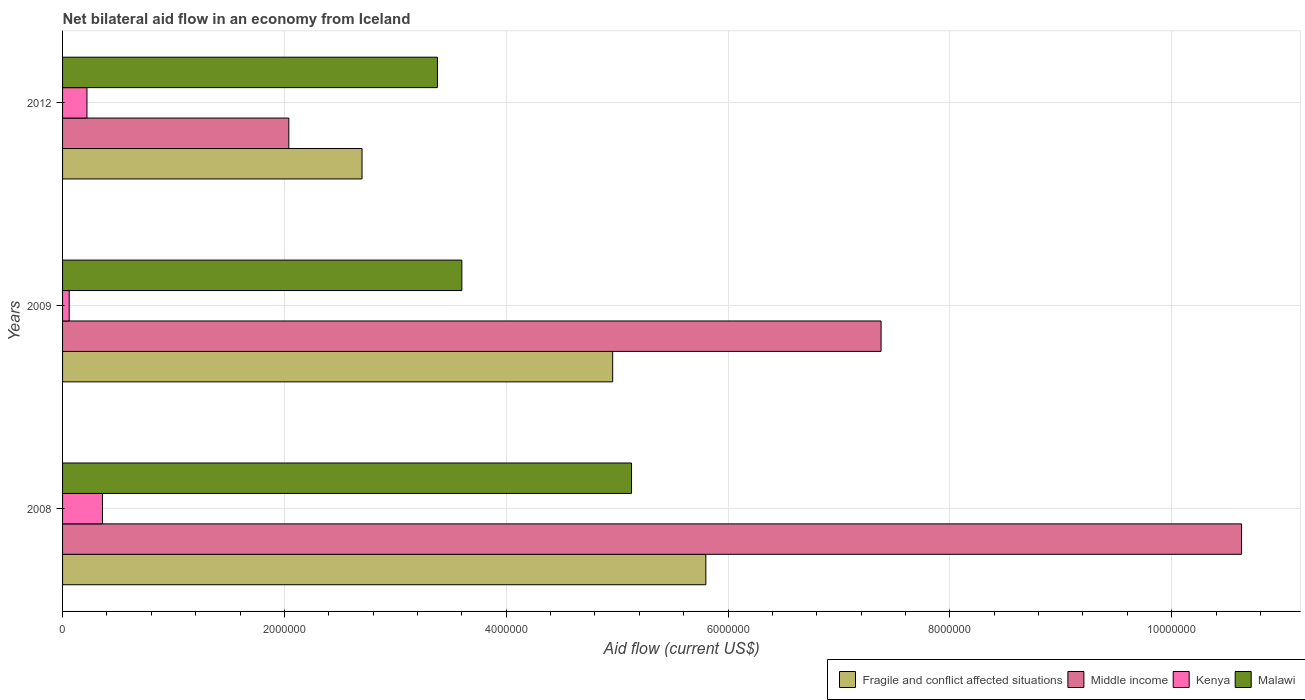How many different coloured bars are there?
Provide a succinct answer. 4. How many groups of bars are there?
Your response must be concise. 3. Are the number of bars per tick equal to the number of legend labels?
Offer a very short reply. Yes. Are the number of bars on each tick of the Y-axis equal?
Provide a short and direct response. Yes. How many bars are there on the 3rd tick from the top?
Keep it short and to the point. 4. What is the net bilateral aid flow in Kenya in 2009?
Your answer should be compact. 6.00e+04. Across all years, what is the minimum net bilateral aid flow in Malawi?
Your response must be concise. 3.38e+06. In which year was the net bilateral aid flow in Kenya maximum?
Provide a succinct answer. 2008. In which year was the net bilateral aid flow in Malawi minimum?
Keep it short and to the point. 2012. What is the total net bilateral aid flow in Middle income in the graph?
Your response must be concise. 2.00e+07. What is the difference between the net bilateral aid flow in Malawi in 2009 and that in 2012?
Your response must be concise. 2.20e+05. What is the difference between the net bilateral aid flow in Malawi in 2009 and the net bilateral aid flow in Middle income in 2012?
Make the answer very short. 1.56e+06. What is the average net bilateral aid flow in Kenya per year?
Your answer should be very brief. 2.13e+05. In the year 2008, what is the difference between the net bilateral aid flow in Middle income and net bilateral aid flow in Kenya?
Your response must be concise. 1.03e+07. In how many years, is the net bilateral aid flow in Kenya greater than 3600000 US$?
Offer a terse response. 0. What is the ratio of the net bilateral aid flow in Middle income in 2008 to that in 2009?
Offer a terse response. 1.44. What is the difference between the highest and the second highest net bilateral aid flow in Fragile and conflict affected situations?
Provide a short and direct response. 8.40e+05. What is the difference between the highest and the lowest net bilateral aid flow in Middle income?
Your answer should be compact. 8.59e+06. In how many years, is the net bilateral aid flow in Kenya greater than the average net bilateral aid flow in Kenya taken over all years?
Offer a terse response. 2. Is the sum of the net bilateral aid flow in Middle income in 2008 and 2012 greater than the maximum net bilateral aid flow in Malawi across all years?
Give a very brief answer. Yes. Is it the case that in every year, the sum of the net bilateral aid flow in Kenya and net bilateral aid flow in Fragile and conflict affected situations is greater than the sum of net bilateral aid flow in Middle income and net bilateral aid flow in Malawi?
Provide a short and direct response. Yes. What does the 4th bar from the top in 2008 represents?
Ensure brevity in your answer.  Fragile and conflict affected situations. What does the 4th bar from the bottom in 2012 represents?
Your answer should be compact. Malawi. Are all the bars in the graph horizontal?
Keep it short and to the point. Yes. How many years are there in the graph?
Ensure brevity in your answer.  3. Are the values on the major ticks of X-axis written in scientific E-notation?
Provide a short and direct response. No. Where does the legend appear in the graph?
Make the answer very short. Bottom right. How many legend labels are there?
Your answer should be very brief. 4. What is the title of the graph?
Make the answer very short. Net bilateral aid flow in an economy from Iceland. What is the label or title of the X-axis?
Your response must be concise. Aid flow (current US$). What is the Aid flow (current US$) in Fragile and conflict affected situations in 2008?
Keep it short and to the point. 5.80e+06. What is the Aid flow (current US$) in Middle income in 2008?
Provide a short and direct response. 1.06e+07. What is the Aid flow (current US$) of Malawi in 2008?
Keep it short and to the point. 5.13e+06. What is the Aid flow (current US$) in Fragile and conflict affected situations in 2009?
Ensure brevity in your answer.  4.96e+06. What is the Aid flow (current US$) in Middle income in 2009?
Offer a terse response. 7.38e+06. What is the Aid flow (current US$) in Kenya in 2009?
Make the answer very short. 6.00e+04. What is the Aid flow (current US$) of Malawi in 2009?
Offer a terse response. 3.60e+06. What is the Aid flow (current US$) of Fragile and conflict affected situations in 2012?
Make the answer very short. 2.70e+06. What is the Aid flow (current US$) of Middle income in 2012?
Give a very brief answer. 2.04e+06. What is the Aid flow (current US$) of Malawi in 2012?
Offer a terse response. 3.38e+06. Across all years, what is the maximum Aid flow (current US$) of Fragile and conflict affected situations?
Offer a very short reply. 5.80e+06. Across all years, what is the maximum Aid flow (current US$) of Middle income?
Provide a succinct answer. 1.06e+07. Across all years, what is the maximum Aid flow (current US$) of Kenya?
Give a very brief answer. 3.60e+05. Across all years, what is the maximum Aid flow (current US$) of Malawi?
Provide a short and direct response. 5.13e+06. Across all years, what is the minimum Aid flow (current US$) in Fragile and conflict affected situations?
Keep it short and to the point. 2.70e+06. Across all years, what is the minimum Aid flow (current US$) of Middle income?
Your response must be concise. 2.04e+06. Across all years, what is the minimum Aid flow (current US$) in Malawi?
Provide a succinct answer. 3.38e+06. What is the total Aid flow (current US$) of Fragile and conflict affected situations in the graph?
Your answer should be compact. 1.35e+07. What is the total Aid flow (current US$) in Middle income in the graph?
Your response must be concise. 2.00e+07. What is the total Aid flow (current US$) of Kenya in the graph?
Your response must be concise. 6.40e+05. What is the total Aid flow (current US$) of Malawi in the graph?
Ensure brevity in your answer.  1.21e+07. What is the difference between the Aid flow (current US$) of Fragile and conflict affected situations in 2008 and that in 2009?
Provide a short and direct response. 8.40e+05. What is the difference between the Aid flow (current US$) of Middle income in 2008 and that in 2009?
Offer a very short reply. 3.25e+06. What is the difference between the Aid flow (current US$) of Malawi in 2008 and that in 2009?
Your answer should be compact. 1.53e+06. What is the difference between the Aid flow (current US$) of Fragile and conflict affected situations in 2008 and that in 2012?
Your answer should be very brief. 3.10e+06. What is the difference between the Aid flow (current US$) in Middle income in 2008 and that in 2012?
Give a very brief answer. 8.59e+06. What is the difference between the Aid flow (current US$) of Malawi in 2008 and that in 2012?
Give a very brief answer. 1.75e+06. What is the difference between the Aid flow (current US$) in Fragile and conflict affected situations in 2009 and that in 2012?
Offer a terse response. 2.26e+06. What is the difference between the Aid flow (current US$) in Middle income in 2009 and that in 2012?
Keep it short and to the point. 5.34e+06. What is the difference between the Aid flow (current US$) in Kenya in 2009 and that in 2012?
Your answer should be very brief. -1.60e+05. What is the difference between the Aid flow (current US$) in Malawi in 2009 and that in 2012?
Your answer should be compact. 2.20e+05. What is the difference between the Aid flow (current US$) in Fragile and conflict affected situations in 2008 and the Aid flow (current US$) in Middle income in 2009?
Offer a terse response. -1.58e+06. What is the difference between the Aid flow (current US$) of Fragile and conflict affected situations in 2008 and the Aid flow (current US$) of Kenya in 2009?
Your answer should be very brief. 5.74e+06. What is the difference between the Aid flow (current US$) of Fragile and conflict affected situations in 2008 and the Aid flow (current US$) of Malawi in 2009?
Your answer should be very brief. 2.20e+06. What is the difference between the Aid flow (current US$) in Middle income in 2008 and the Aid flow (current US$) in Kenya in 2009?
Provide a succinct answer. 1.06e+07. What is the difference between the Aid flow (current US$) in Middle income in 2008 and the Aid flow (current US$) in Malawi in 2009?
Make the answer very short. 7.03e+06. What is the difference between the Aid flow (current US$) of Kenya in 2008 and the Aid flow (current US$) of Malawi in 2009?
Your response must be concise. -3.24e+06. What is the difference between the Aid flow (current US$) in Fragile and conflict affected situations in 2008 and the Aid flow (current US$) in Middle income in 2012?
Make the answer very short. 3.76e+06. What is the difference between the Aid flow (current US$) of Fragile and conflict affected situations in 2008 and the Aid flow (current US$) of Kenya in 2012?
Keep it short and to the point. 5.58e+06. What is the difference between the Aid flow (current US$) in Fragile and conflict affected situations in 2008 and the Aid flow (current US$) in Malawi in 2012?
Provide a succinct answer. 2.42e+06. What is the difference between the Aid flow (current US$) in Middle income in 2008 and the Aid flow (current US$) in Kenya in 2012?
Provide a short and direct response. 1.04e+07. What is the difference between the Aid flow (current US$) in Middle income in 2008 and the Aid flow (current US$) in Malawi in 2012?
Ensure brevity in your answer.  7.25e+06. What is the difference between the Aid flow (current US$) of Kenya in 2008 and the Aid flow (current US$) of Malawi in 2012?
Your answer should be very brief. -3.02e+06. What is the difference between the Aid flow (current US$) in Fragile and conflict affected situations in 2009 and the Aid flow (current US$) in Middle income in 2012?
Your response must be concise. 2.92e+06. What is the difference between the Aid flow (current US$) of Fragile and conflict affected situations in 2009 and the Aid flow (current US$) of Kenya in 2012?
Your response must be concise. 4.74e+06. What is the difference between the Aid flow (current US$) in Fragile and conflict affected situations in 2009 and the Aid flow (current US$) in Malawi in 2012?
Keep it short and to the point. 1.58e+06. What is the difference between the Aid flow (current US$) in Middle income in 2009 and the Aid flow (current US$) in Kenya in 2012?
Give a very brief answer. 7.16e+06. What is the difference between the Aid flow (current US$) of Kenya in 2009 and the Aid flow (current US$) of Malawi in 2012?
Keep it short and to the point. -3.32e+06. What is the average Aid flow (current US$) of Fragile and conflict affected situations per year?
Keep it short and to the point. 4.49e+06. What is the average Aid flow (current US$) in Middle income per year?
Give a very brief answer. 6.68e+06. What is the average Aid flow (current US$) of Kenya per year?
Provide a short and direct response. 2.13e+05. What is the average Aid flow (current US$) of Malawi per year?
Ensure brevity in your answer.  4.04e+06. In the year 2008, what is the difference between the Aid flow (current US$) in Fragile and conflict affected situations and Aid flow (current US$) in Middle income?
Provide a short and direct response. -4.83e+06. In the year 2008, what is the difference between the Aid flow (current US$) of Fragile and conflict affected situations and Aid flow (current US$) of Kenya?
Keep it short and to the point. 5.44e+06. In the year 2008, what is the difference between the Aid flow (current US$) of Fragile and conflict affected situations and Aid flow (current US$) of Malawi?
Ensure brevity in your answer.  6.70e+05. In the year 2008, what is the difference between the Aid flow (current US$) in Middle income and Aid flow (current US$) in Kenya?
Your response must be concise. 1.03e+07. In the year 2008, what is the difference between the Aid flow (current US$) in Middle income and Aid flow (current US$) in Malawi?
Provide a succinct answer. 5.50e+06. In the year 2008, what is the difference between the Aid flow (current US$) in Kenya and Aid flow (current US$) in Malawi?
Provide a short and direct response. -4.77e+06. In the year 2009, what is the difference between the Aid flow (current US$) in Fragile and conflict affected situations and Aid flow (current US$) in Middle income?
Offer a terse response. -2.42e+06. In the year 2009, what is the difference between the Aid flow (current US$) of Fragile and conflict affected situations and Aid flow (current US$) of Kenya?
Keep it short and to the point. 4.90e+06. In the year 2009, what is the difference between the Aid flow (current US$) of Fragile and conflict affected situations and Aid flow (current US$) of Malawi?
Keep it short and to the point. 1.36e+06. In the year 2009, what is the difference between the Aid flow (current US$) of Middle income and Aid flow (current US$) of Kenya?
Your answer should be compact. 7.32e+06. In the year 2009, what is the difference between the Aid flow (current US$) of Middle income and Aid flow (current US$) of Malawi?
Provide a short and direct response. 3.78e+06. In the year 2009, what is the difference between the Aid flow (current US$) of Kenya and Aid flow (current US$) of Malawi?
Offer a very short reply. -3.54e+06. In the year 2012, what is the difference between the Aid flow (current US$) in Fragile and conflict affected situations and Aid flow (current US$) in Kenya?
Make the answer very short. 2.48e+06. In the year 2012, what is the difference between the Aid flow (current US$) of Fragile and conflict affected situations and Aid flow (current US$) of Malawi?
Offer a terse response. -6.80e+05. In the year 2012, what is the difference between the Aid flow (current US$) of Middle income and Aid flow (current US$) of Kenya?
Ensure brevity in your answer.  1.82e+06. In the year 2012, what is the difference between the Aid flow (current US$) in Middle income and Aid flow (current US$) in Malawi?
Offer a very short reply. -1.34e+06. In the year 2012, what is the difference between the Aid flow (current US$) of Kenya and Aid flow (current US$) of Malawi?
Your answer should be compact. -3.16e+06. What is the ratio of the Aid flow (current US$) of Fragile and conflict affected situations in 2008 to that in 2009?
Your response must be concise. 1.17. What is the ratio of the Aid flow (current US$) in Middle income in 2008 to that in 2009?
Make the answer very short. 1.44. What is the ratio of the Aid flow (current US$) in Malawi in 2008 to that in 2009?
Make the answer very short. 1.43. What is the ratio of the Aid flow (current US$) of Fragile and conflict affected situations in 2008 to that in 2012?
Your answer should be compact. 2.15. What is the ratio of the Aid flow (current US$) of Middle income in 2008 to that in 2012?
Make the answer very short. 5.21. What is the ratio of the Aid flow (current US$) of Kenya in 2008 to that in 2012?
Keep it short and to the point. 1.64. What is the ratio of the Aid flow (current US$) of Malawi in 2008 to that in 2012?
Your answer should be very brief. 1.52. What is the ratio of the Aid flow (current US$) in Fragile and conflict affected situations in 2009 to that in 2012?
Provide a short and direct response. 1.84. What is the ratio of the Aid flow (current US$) in Middle income in 2009 to that in 2012?
Provide a succinct answer. 3.62. What is the ratio of the Aid flow (current US$) in Kenya in 2009 to that in 2012?
Your answer should be very brief. 0.27. What is the ratio of the Aid flow (current US$) in Malawi in 2009 to that in 2012?
Offer a terse response. 1.07. What is the difference between the highest and the second highest Aid flow (current US$) in Fragile and conflict affected situations?
Make the answer very short. 8.40e+05. What is the difference between the highest and the second highest Aid flow (current US$) in Middle income?
Offer a very short reply. 3.25e+06. What is the difference between the highest and the second highest Aid flow (current US$) of Kenya?
Your answer should be very brief. 1.40e+05. What is the difference between the highest and the second highest Aid flow (current US$) in Malawi?
Keep it short and to the point. 1.53e+06. What is the difference between the highest and the lowest Aid flow (current US$) in Fragile and conflict affected situations?
Provide a short and direct response. 3.10e+06. What is the difference between the highest and the lowest Aid flow (current US$) of Middle income?
Your answer should be very brief. 8.59e+06. What is the difference between the highest and the lowest Aid flow (current US$) in Malawi?
Provide a short and direct response. 1.75e+06. 